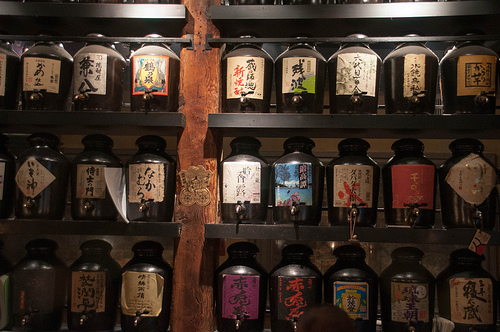<image>
Is there a jar on the shelf? Yes. Looking at the image, I can see the jar is positioned on top of the shelf, with the shelf providing support. Is there a keg behind the shelf? Yes. From this viewpoint, the keg is positioned behind the shelf, with the shelf partially or fully occluding the keg. 